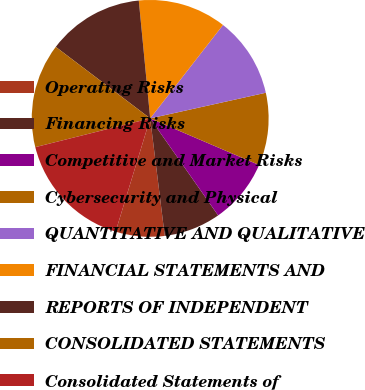Convert chart to OTSL. <chart><loc_0><loc_0><loc_500><loc_500><pie_chart><fcel>Operating Risks<fcel>Financing Risks<fcel>Competitive and Market Risks<fcel>Cybersecurity and Physical<fcel>QUANTITATIVE AND QUALITATIVE<fcel>FINANCIAL STATEMENTS AND<fcel>REPORTS OF INDEPENDENT<fcel>CONSOLIDATED STATEMENTS<fcel>Consolidated Statements of<nl><fcel>6.68%<fcel>7.76%<fcel>8.84%<fcel>9.91%<fcel>10.99%<fcel>12.07%<fcel>13.15%<fcel>14.22%<fcel>16.38%<nl></chart> 